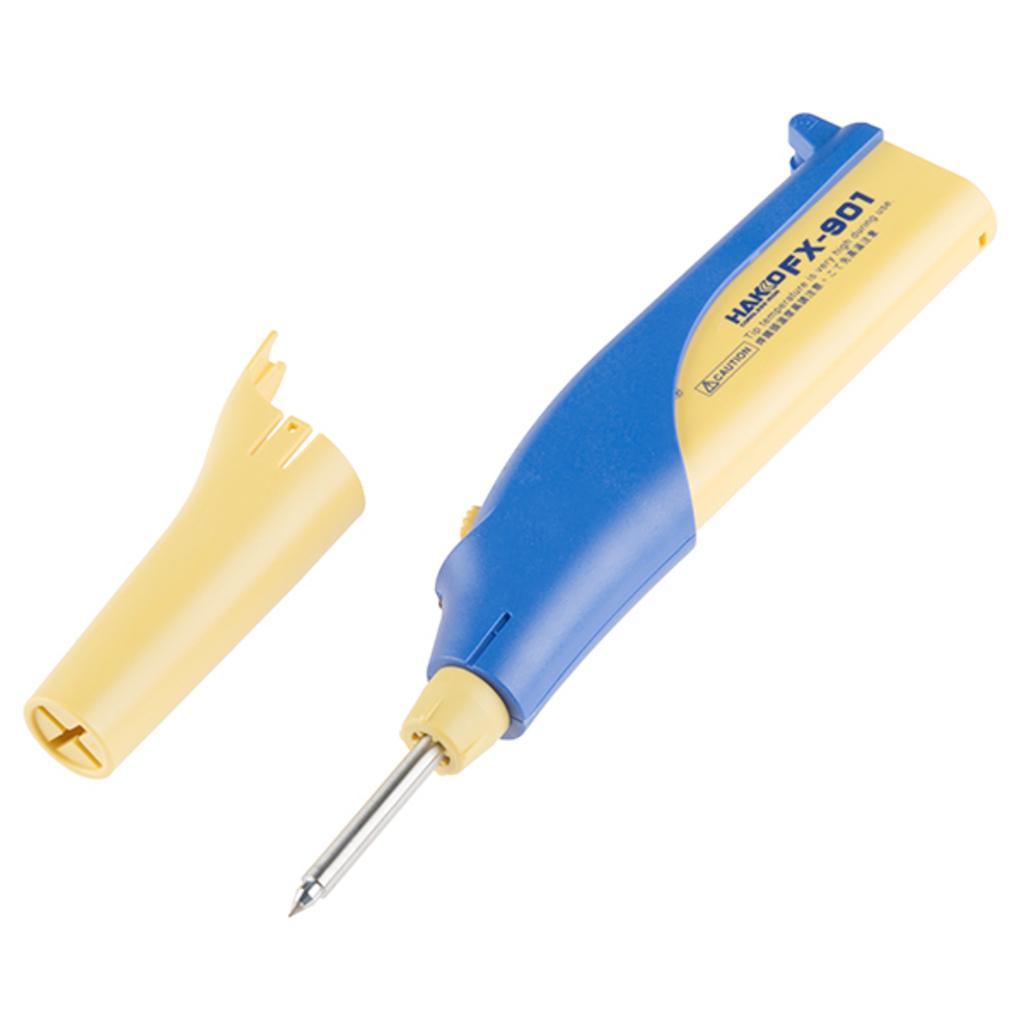Please provide a concise description of this image. In the image there is a soldering iron in yellow and blue color. Beside that there is a yellow color cap of it. 